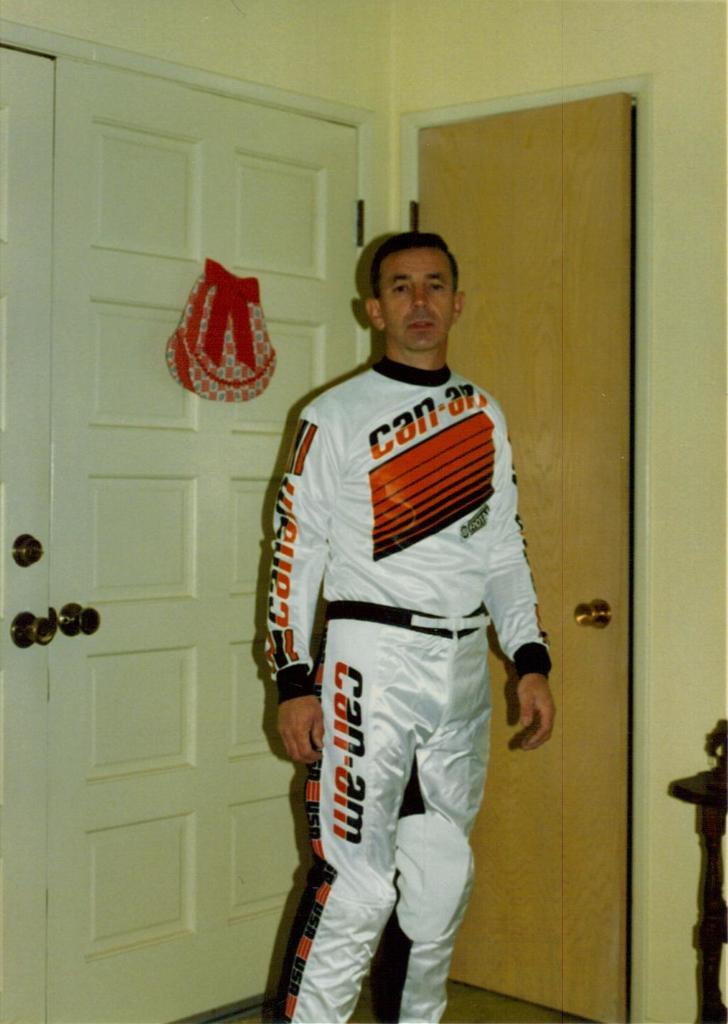Who is the sponsor of this racing uniform?
Offer a very short reply. Can-am. 